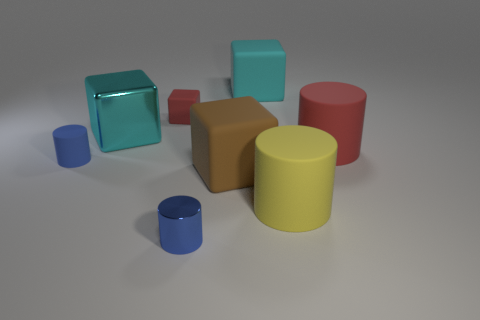The cylinder that is the same color as the tiny rubber block is what size?
Make the answer very short. Large. Is there anything else of the same color as the metallic cylinder?
Provide a short and direct response. Yes. What is the color of the tiny shiny object?
Your response must be concise. Blue. Is the small rubber cylinder the same color as the tiny metal cylinder?
Give a very brief answer. Yes. Do the big cyan cube that is behind the cyan metal thing and the big thing that is left of the small blue metallic cylinder have the same material?
Make the answer very short. No. What is the material of the other tiny blue object that is the same shape as the small blue matte thing?
Offer a terse response. Metal. There is a tiny thing behind the tiny blue object behind the shiny cylinder; what is its color?
Ensure brevity in your answer.  Red. There is a yellow cylinder that is made of the same material as the small cube; what is its size?
Your answer should be compact. Large. What number of blue matte things are the same shape as the big cyan metal object?
Offer a terse response. 0. What number of objects are either cylinders behind the big yellow rubber thing or large red things to the right of the metallic cylinder?
Your answer should be compact. 2. 